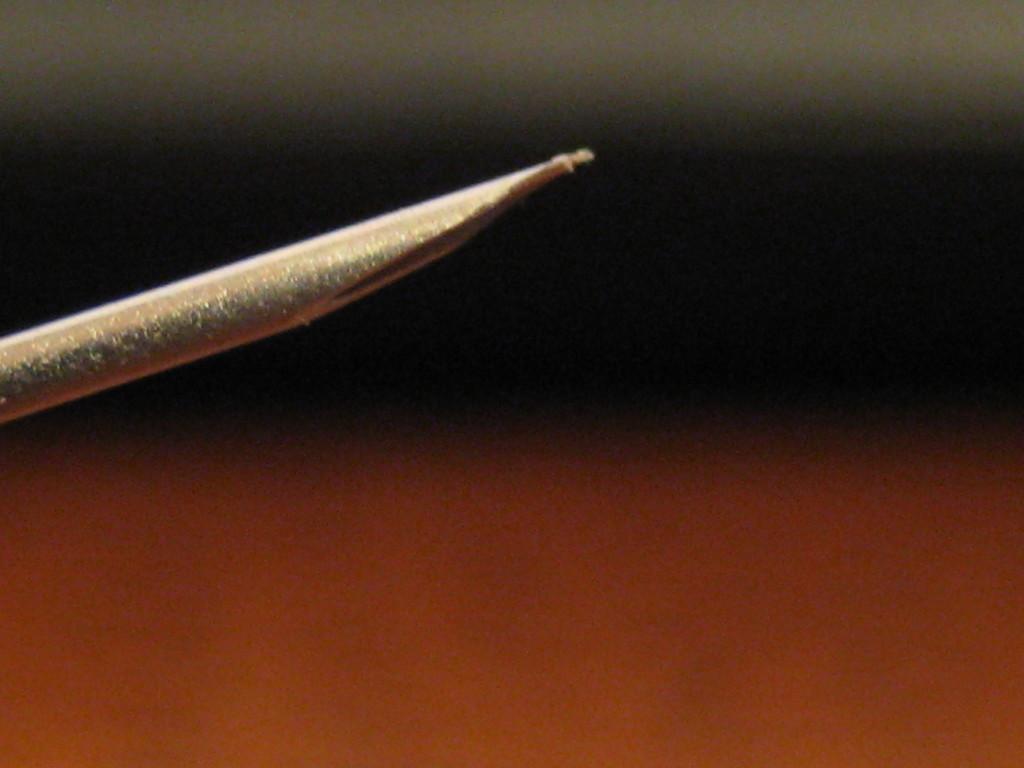Please provide a concise description of this image. In this image I can see an object in the front and it looks like a straw. I can also see tricolor background. 